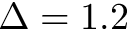<formula> <loc_0><loc_0><loc_500><loc_500>\Delta = 1 . 2</formula> 